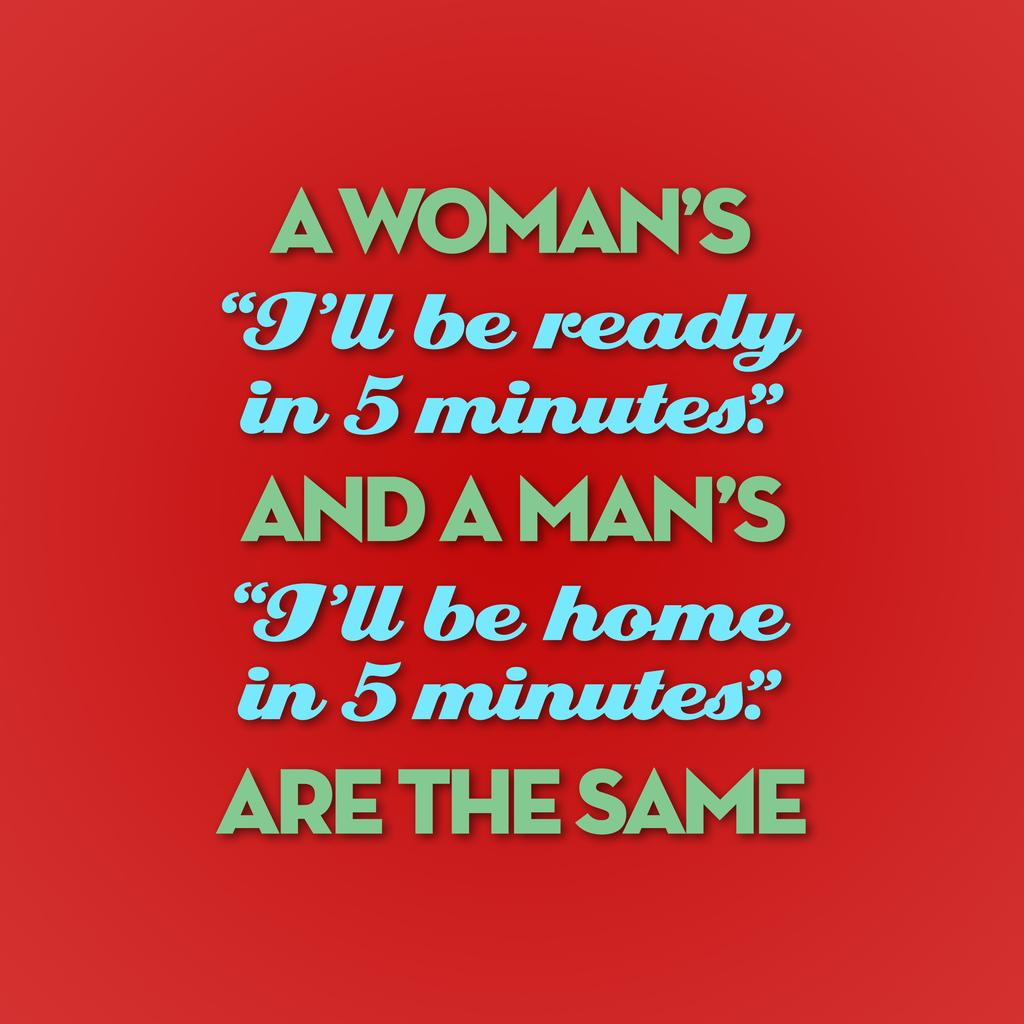<image>
Provide a brief description of the given image. The phrase on the red background begins with "A Woman's 'I'll be ready in 5 minutes'". 